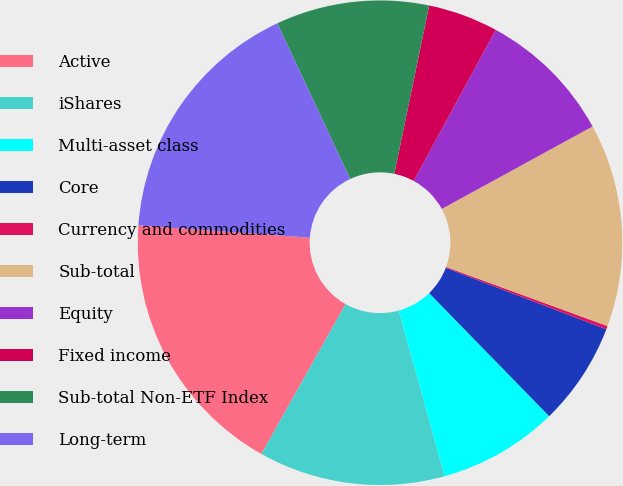<chart> <loc_0><loc_0><loc_500><loc_500><pie_chart><fcel>Active<fcel>iShares<fcel>Multi-asset class<fcel>Core<fcel>Currency and commodities<fcel>Sub-total<fcel>Equity<fcel>Fixed income<fcel>Sub-total Non-ETF Index<fcel>Long-term<nl><fcel>18.0%<fcel>12.44%<fcel>8.0%<fcel>6.89%<fcel>0.22%<fcel>13.56%<fcel>9.11%<fcel>4.67%<fcel>10.22%<fcel>16.89%<nl></chart> 